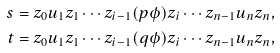<formula> <loc_0><loc_0><loc_500><loc_500>s & = z _ { 0 } u _ { 1 } z _ { 1 } \cdots z _ { i - 1 } ( p \phi ) z _ { i } \cdots z _ { n - 1 } u _ { n } z _ { n } , \\ t & = z _ { 0 } u _ { 1 } z _ { 1 } \cdots z _ { i - 1 } ( q \phi ) z _ { i } \cdots z _ { n - 1 } u _ { n } z _ { n } ,</formula> 